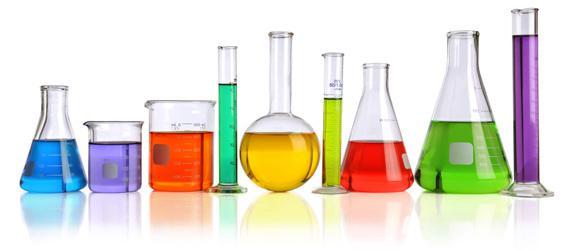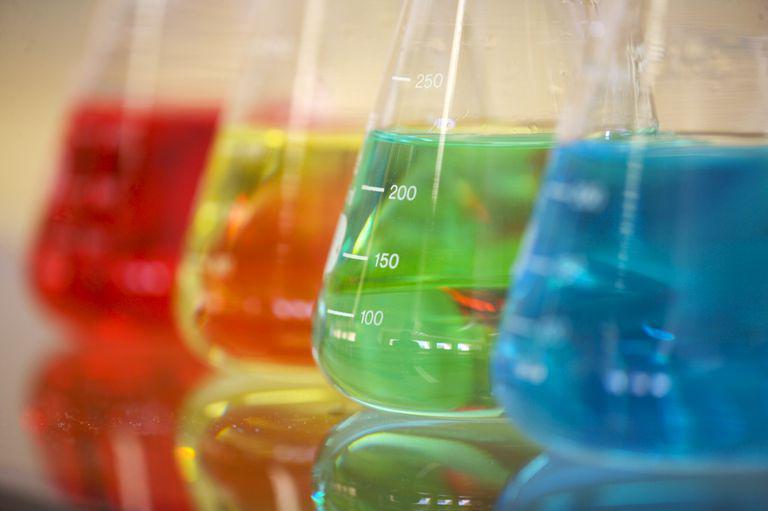The first image is the image on the left, the second image is the image on the right. Analyze the images presented: Is the assertion "Every image shows at least four containers of colored liquid and there are at least four different colors of liquid in each photo." valid? Answer yes or no. Yes. 